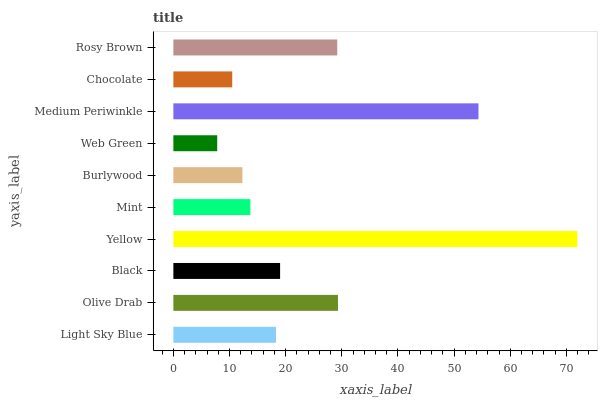Is Web Green the minimum?
Answer yes or no. Yes. Is Yellow the maximum?
Answer yes or no. Yes. Is Olive Drab the minimum?
Answer yes or no. No. Is Olive Drab the maximum?
Answer yes or no. No. Is Olive Drab greater than Light Sky Blue?
Answer yes or no. Yes. Is Light Sky Blue less than Olive Drab?
Answer yes or no. Yes. Is Light Sky Blue greater than Olive Drab?
Answer yes or no. No. Is Olive Drab less than Light Sky Blue?
Answer yes or no. No. Is Black the high median?
Answer yes or no. Yes. Is Light Sky Blue the low median?
Answer yes or no. Yes. Is Mint the high median?
Answer yes or no. No. Is Black the low median?
Answer yes or no. No. 